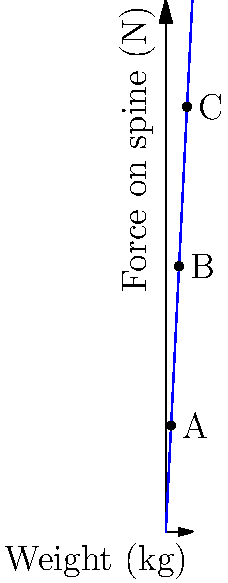The graph shows the relationship between the weight of an object being lifted and the force exerted on the spine. Points A, B, and C represent different lifting scenarios. If the force on the spine at point B is 1000 N, what is the approximate weight of the object being lifted at this point? To solve this problem, we need to follow these steps:

1. Understand the graph:
   - The x-axis represents the weight of the object in kg.
   - The y-axis represents the force on the spine in N.
   - The relationship appears to be linear.

2. Identify the known information:
   - At point B, the force on the spine is 1000 N.

3. Determine the relationship between weight and force:
   - We can see that the line passes through the origin, suggesting a direct proportion.
   - The equation for this line would be of the form $y = kx$, where $k$ is the slope.

4. Calculate the slope (k):
   - We can use point C to calculate the slope: (80 kg, 1600 N)
   - $k = \frac{1600 N}{80 kg} = 20 N/kg$

5. Use the equation to find the weight at point B:
   - $1000 N = 20 N/kg * x$
   - $x = \frac{1000 N}{20 N/kg} = 50 kg$

Therefore, the weight of the object being lifted at point B is approximately 50 kg.
Answer: 50 kg 